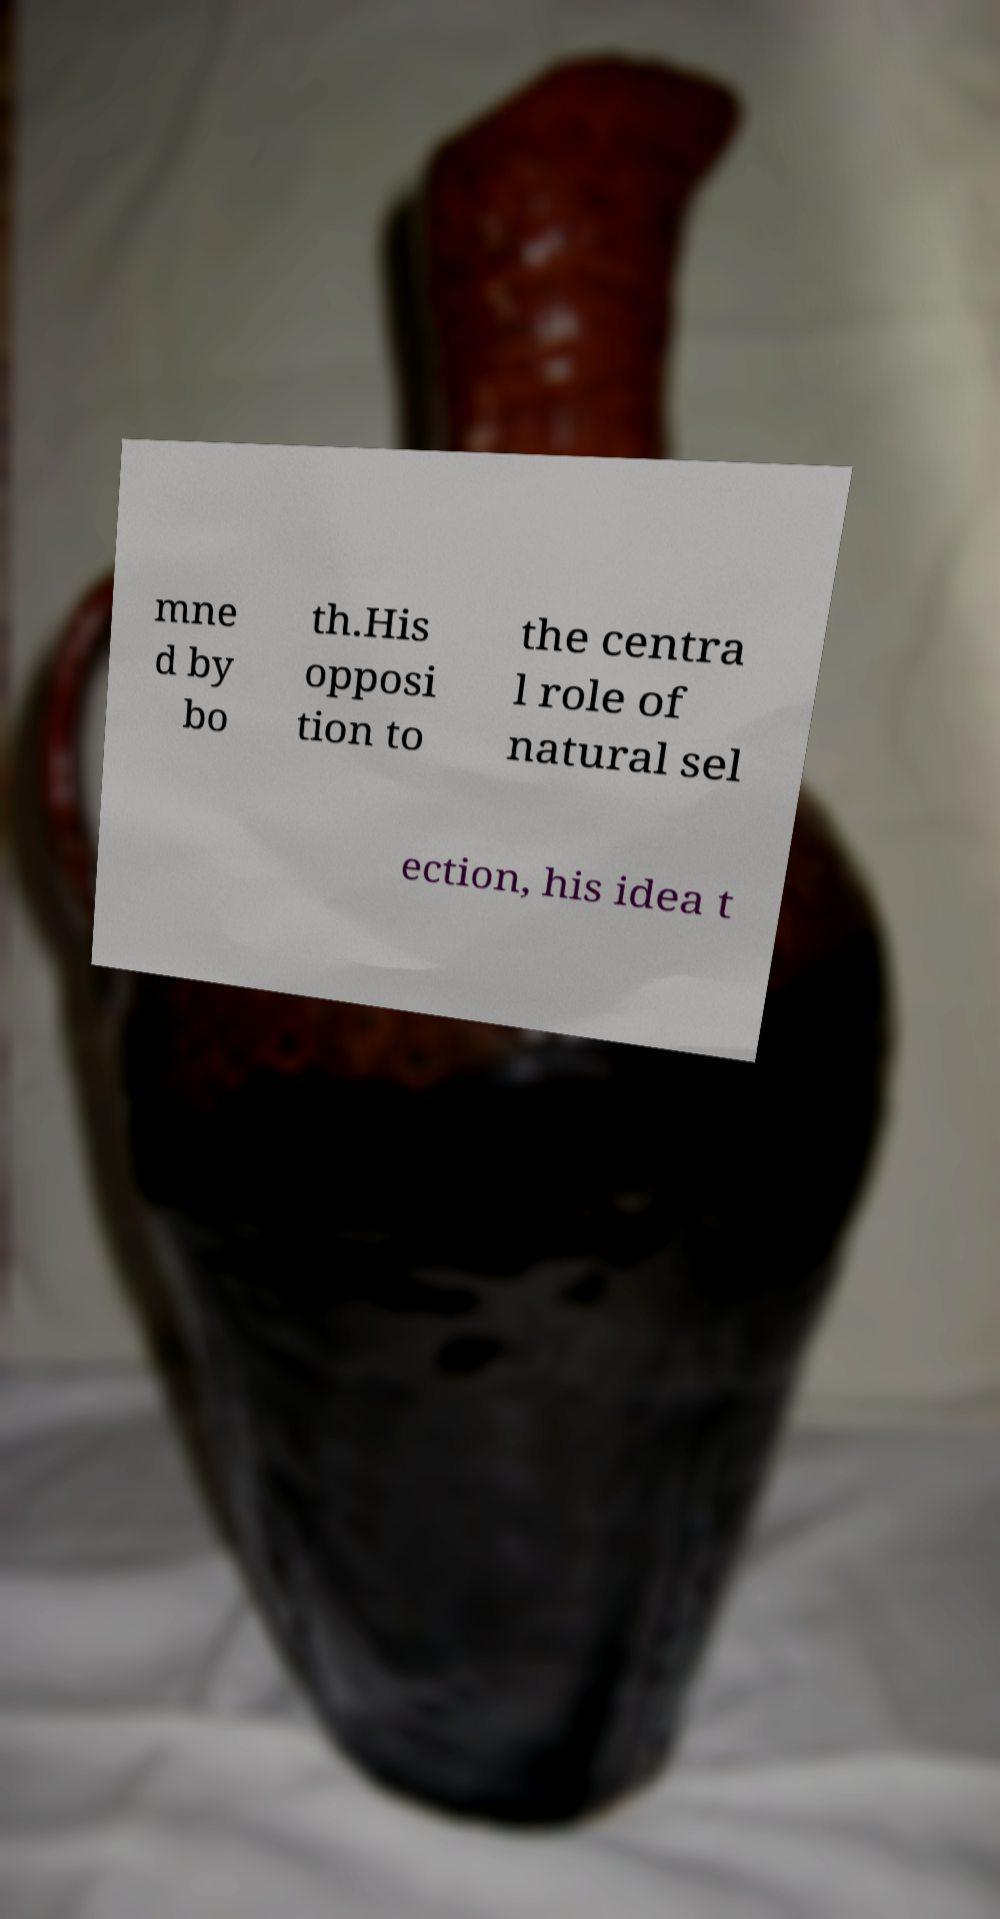What messages or text are displayed in this image? I need them in a readable, typed format. mne d by bo th.His opposi tion to the centra l role of natural sel ection, his idea t 